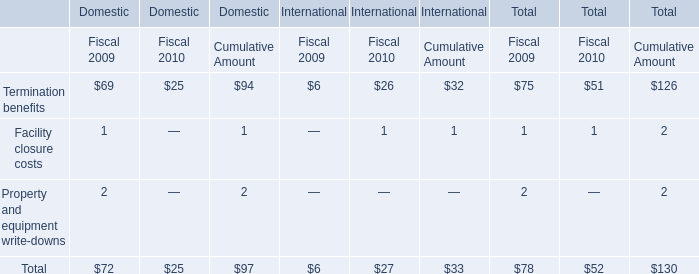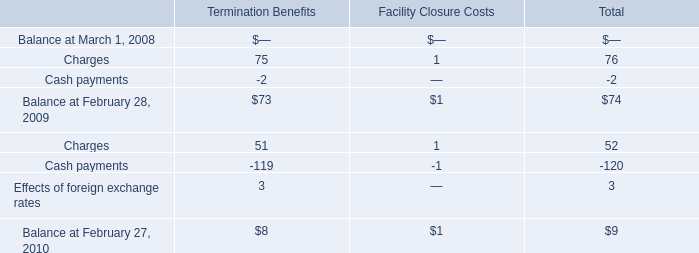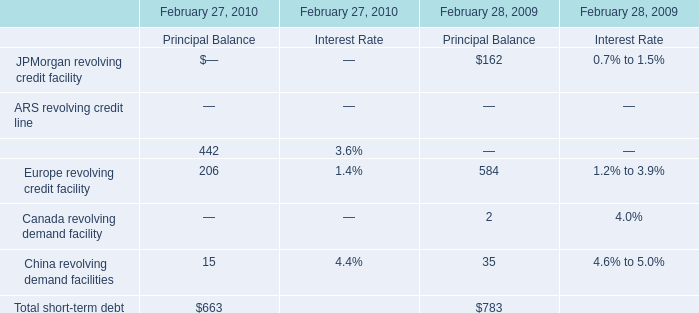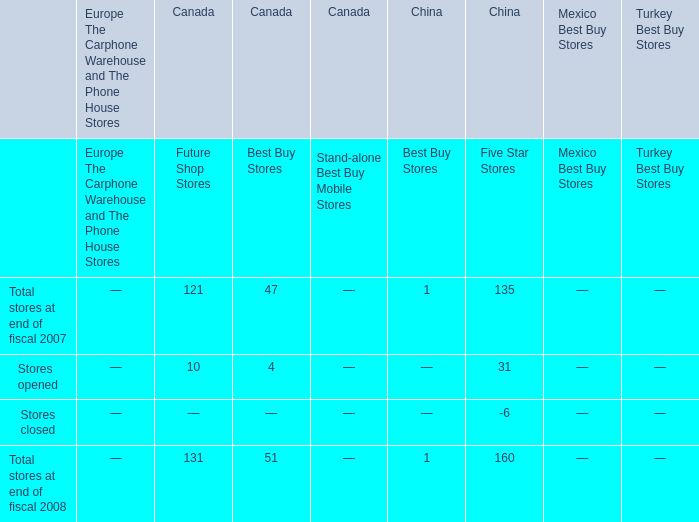If Europe revolving credit facility develops with the same growth rate in 2010, what will it reach in 2011? 
Computations: ((1 + ((206 - 584) / 584)) * 206)
Answer: 72.66438. 